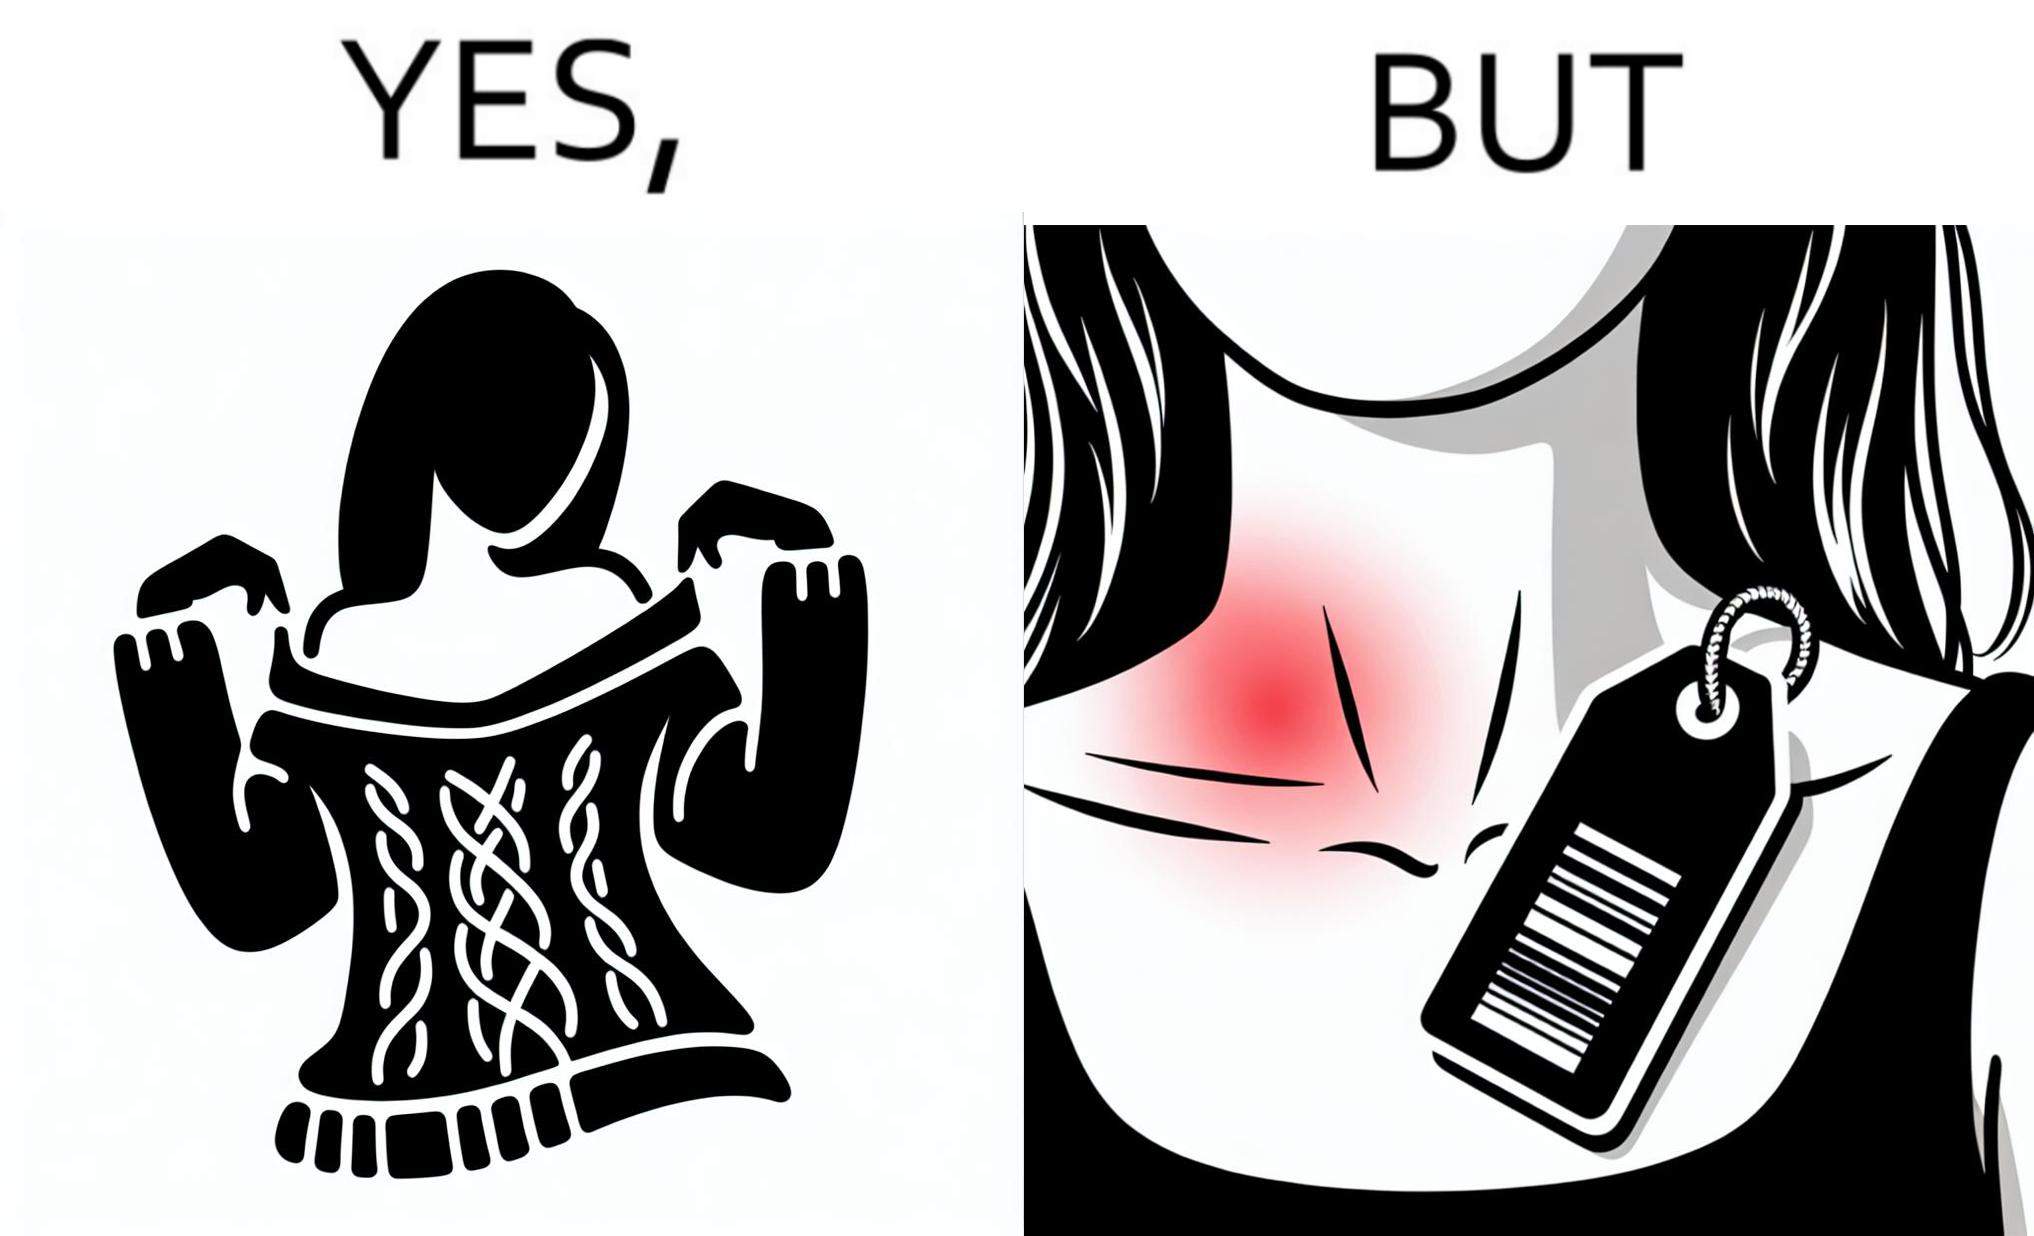Describe the satirical element in this image. The images are funny since it shows how even though sweaters and other clothings provide much comfort, a tiny manufacturers tag ends up causing the user a lot of discomfort due to constant scratching 